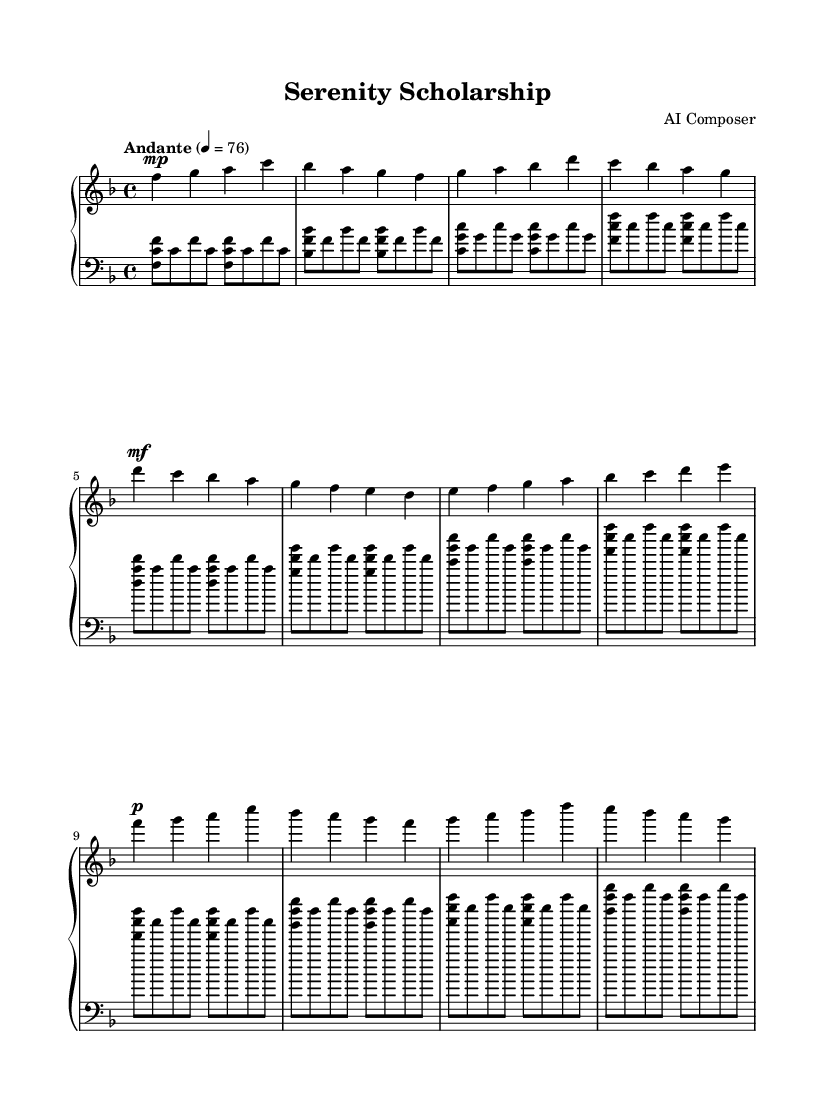What is the key signature of this music? The key signature is F major, which has one flat (B flat).
Answer: F major What is the time signature of this music? The time signature is 4/4, indicating four beats per measure.
Answer: 4/4 What is the tempo marking of this piece? The tempo marking is "Andante," suggesting a moderate pace.
Answer: Andante Which clef is used for the left hand? The left-hand part uses the bass clef, which is standard for lower pitches.
Answer: Bass clef How many measures are in the right-hand part? By counting the measures in the right-hand notation, we find there are eight measures.
Answer: Eight measures What is the dynamic marking at the beginning of the right-hand part? The dynamic marking at the beginning is "mp," which stands for mezzo-piano, indicating a moderately soft sound.
Answer: mezzo-piano What is the final chord in the left-hand part? The final chord consists of the notes F, C, and F, playing together as a triad.
Answer: F, C, F 